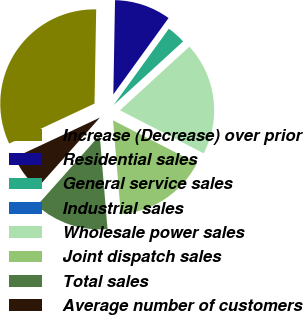Convert chart. <chart><loc_0><loc_0><loc_500><loc_500><pie_chart><fcel>Increase (Decrease) over prior<fcel>Residential sales<fcel>General service sales<fcel>Industrial sales<fcel>Wholesale power sales<fcel>Joint dispatch sales<fcel>Total sales<fcel>Average number of customers<nl><fcel>32.26%<fcel>9.68%<fcel>3.23%<fcel>0.0%<fcel>19.35%<fcel>16.13%<fcel>12.9%<fcel>6.45%<nl></chart> 